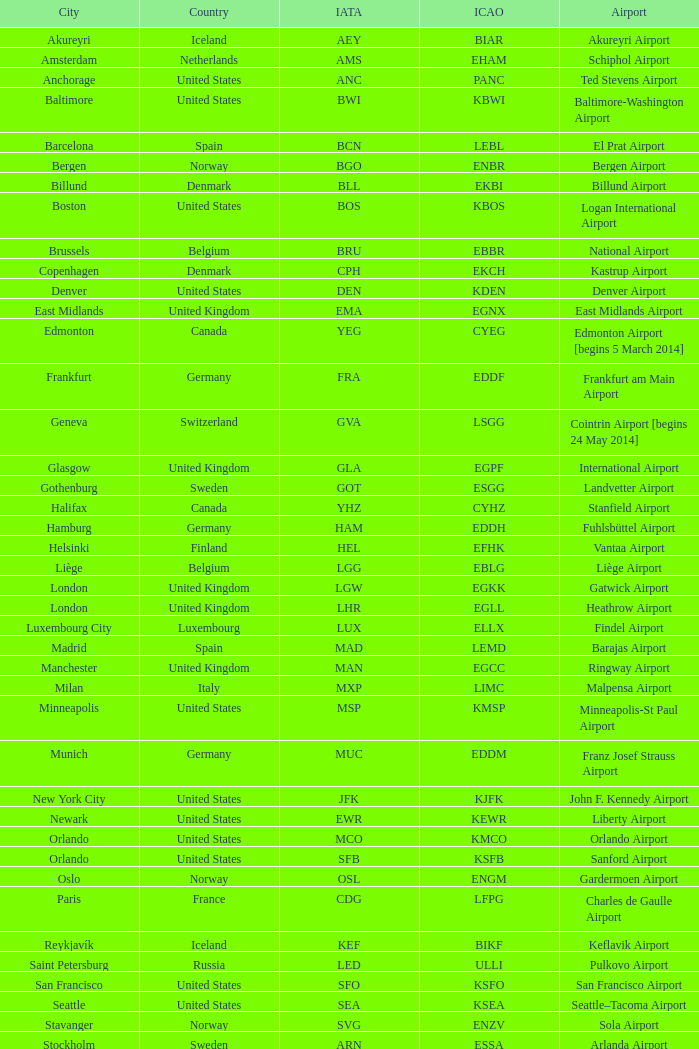What is the Airport with a ICAO of EDDH? Fuhlsbüttel Airport. 